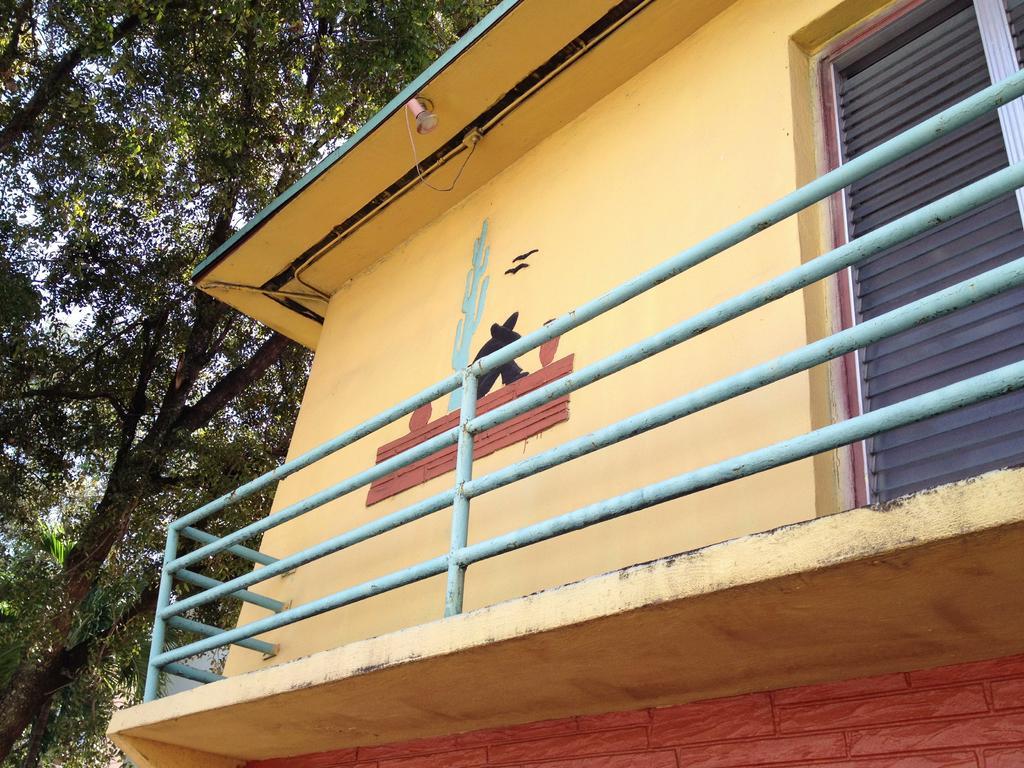How would you summarize this image in a sentence or two? In this image there is a house , there are trees, and in the background there is sky. 